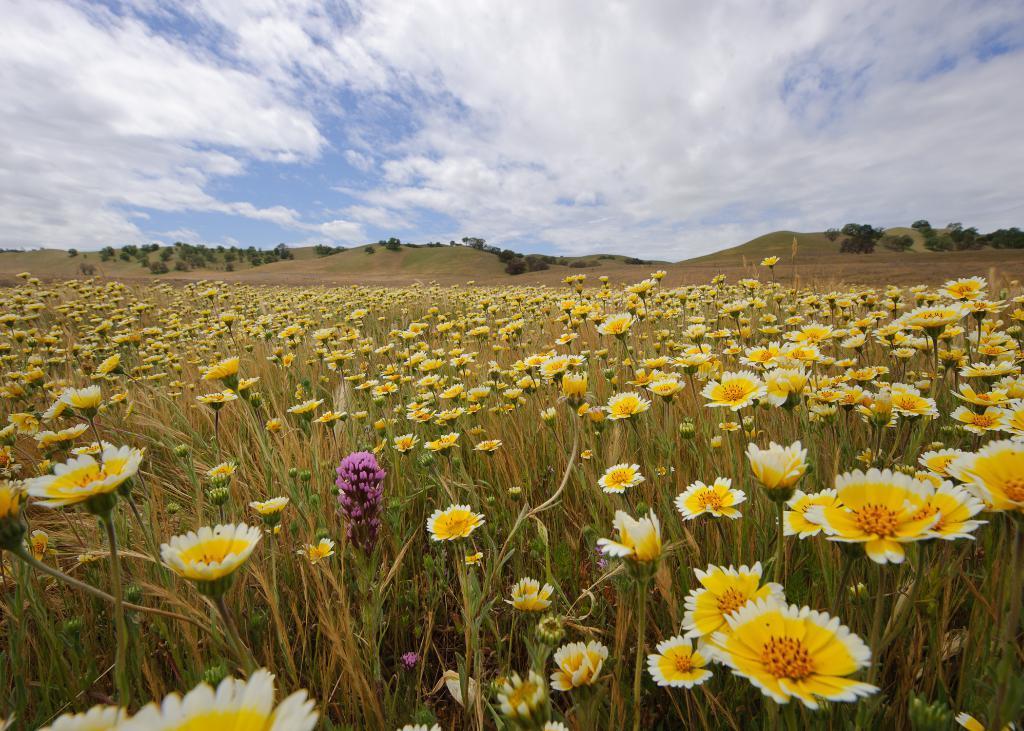Please provide a concise description of this image. As we can see in the image there are plants, flowers, sky, clouds and in the background there are trees. 